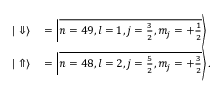<formula> <loc_0><loc_0><loc_500><loc_500>\begin{array} { r l } { | \Downarrow \rangle } & = \left | \overline { { n = 4 9 , l = 1 , j = \frac { 3 } { 2 } , m _ { j } = + \frac { 1 } { 2 } } } \right \rangle } \\ { | \Uparrow \rangle } & = \left | \overline { { n = 4 8 , l = 2 , j = \frac { 5 } { 2 } , m _ { j } = + \frac { 3 } { 2 } } } \right \rangle . } \end{array}</formula> 